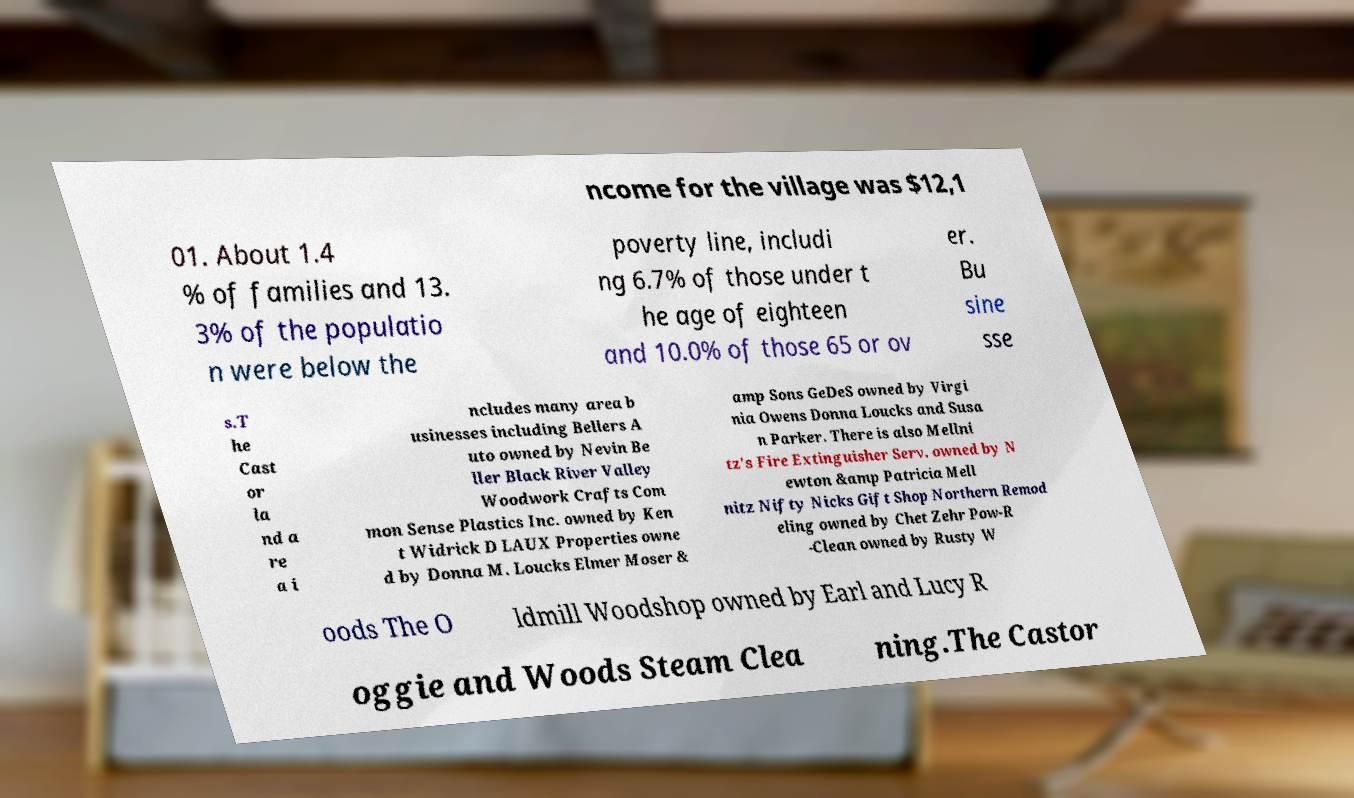Could you assist in decoding the text presented in this image and type it out clearly? ncome for the village was $12,1 01. About 1.4 % of families and 13. 3% of the populatio n were below the poverty line, includi ng 6.7% of those under t he age of eighteen and 10.0% of those 65 or ov er. Bu sine sse s.T he Cast or la nd a re a i ncludes many area b usinesses including Bellers A uto owned by Nevin Be ller Black River Valley Woodwork Crafts Com mon Sense Plastics Inc. owned by Ken t Widrick D LAUX Properties owne d by Donna M. Loucks Elmer Moser & amp Sons GeDeS owned by Virgi nia Owens Donna Loucks and Susa n Parker. There is also Mellni tz's Fire Extinguisher Serv. owned by N ewton &amp Patricia Mell nitz Nifty Nicks Gift Shop Northern Remod eling owned by Chet Zehr Pow-R -Clean owned by Rusty W oods The O ldmill Woodshop owned by Earl and Lucy R oggie and Woods Steam Clea ning.The Castor 